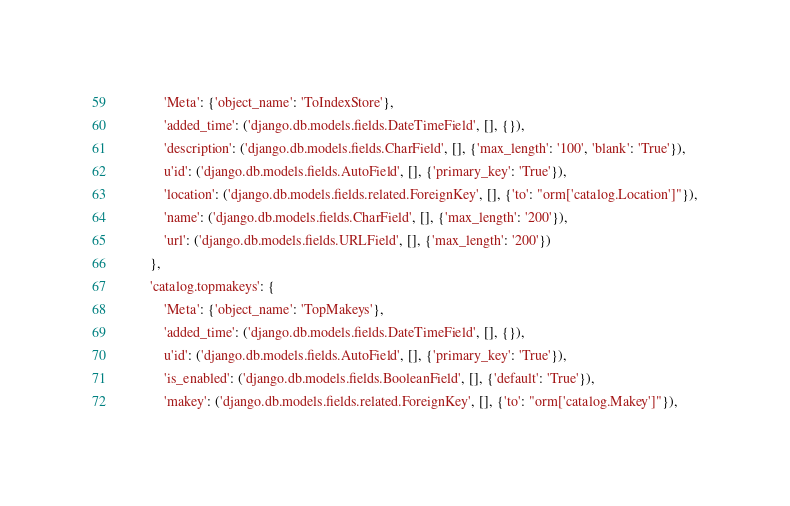Convert code to text. <code><loc_0><loc_0><loc_500><loc_500><_Python_>            'Meta': {'object_name': 'ToIndexStore'},
            'added_time': ('django.db.models.fields.DateTimeField', [], {}),
            'description': ('django.db.models.fields.CharField', [], {'max_length': '100', 'blank': 'True'}),
            u'id': ('django.db.models.fields.AutoField', [], {'primary_key': 'True'}),
            'location': ('django.db.models.fields.related.ForeignKey', [], {'to': "orm['catalog.Location']"}),
            'name': ('django.db.models.fields.CharField', [], {'max_length': '200'}),
            'url': ('django.db.models.fields.URLField', [], {'max_length': '200'})
        },
        'catalog.topmakeys': {
            'Meta': {'object_name': 'TopMakeys'},
            'added_time': ('django.db.models.fields.DateTimeField', [], {}),
            u'id': ('django.db.models.fields.AutoField', [], {'primary_key': 'True'}),
            'is_enabled': ('django.db.models.fields.BooleanField', [], {'default': 'True'}),
            'makey': ('django.db.models.fields.related.ForeignKey', [], {'to': "orm['catalog.Makey']"}),</code> 